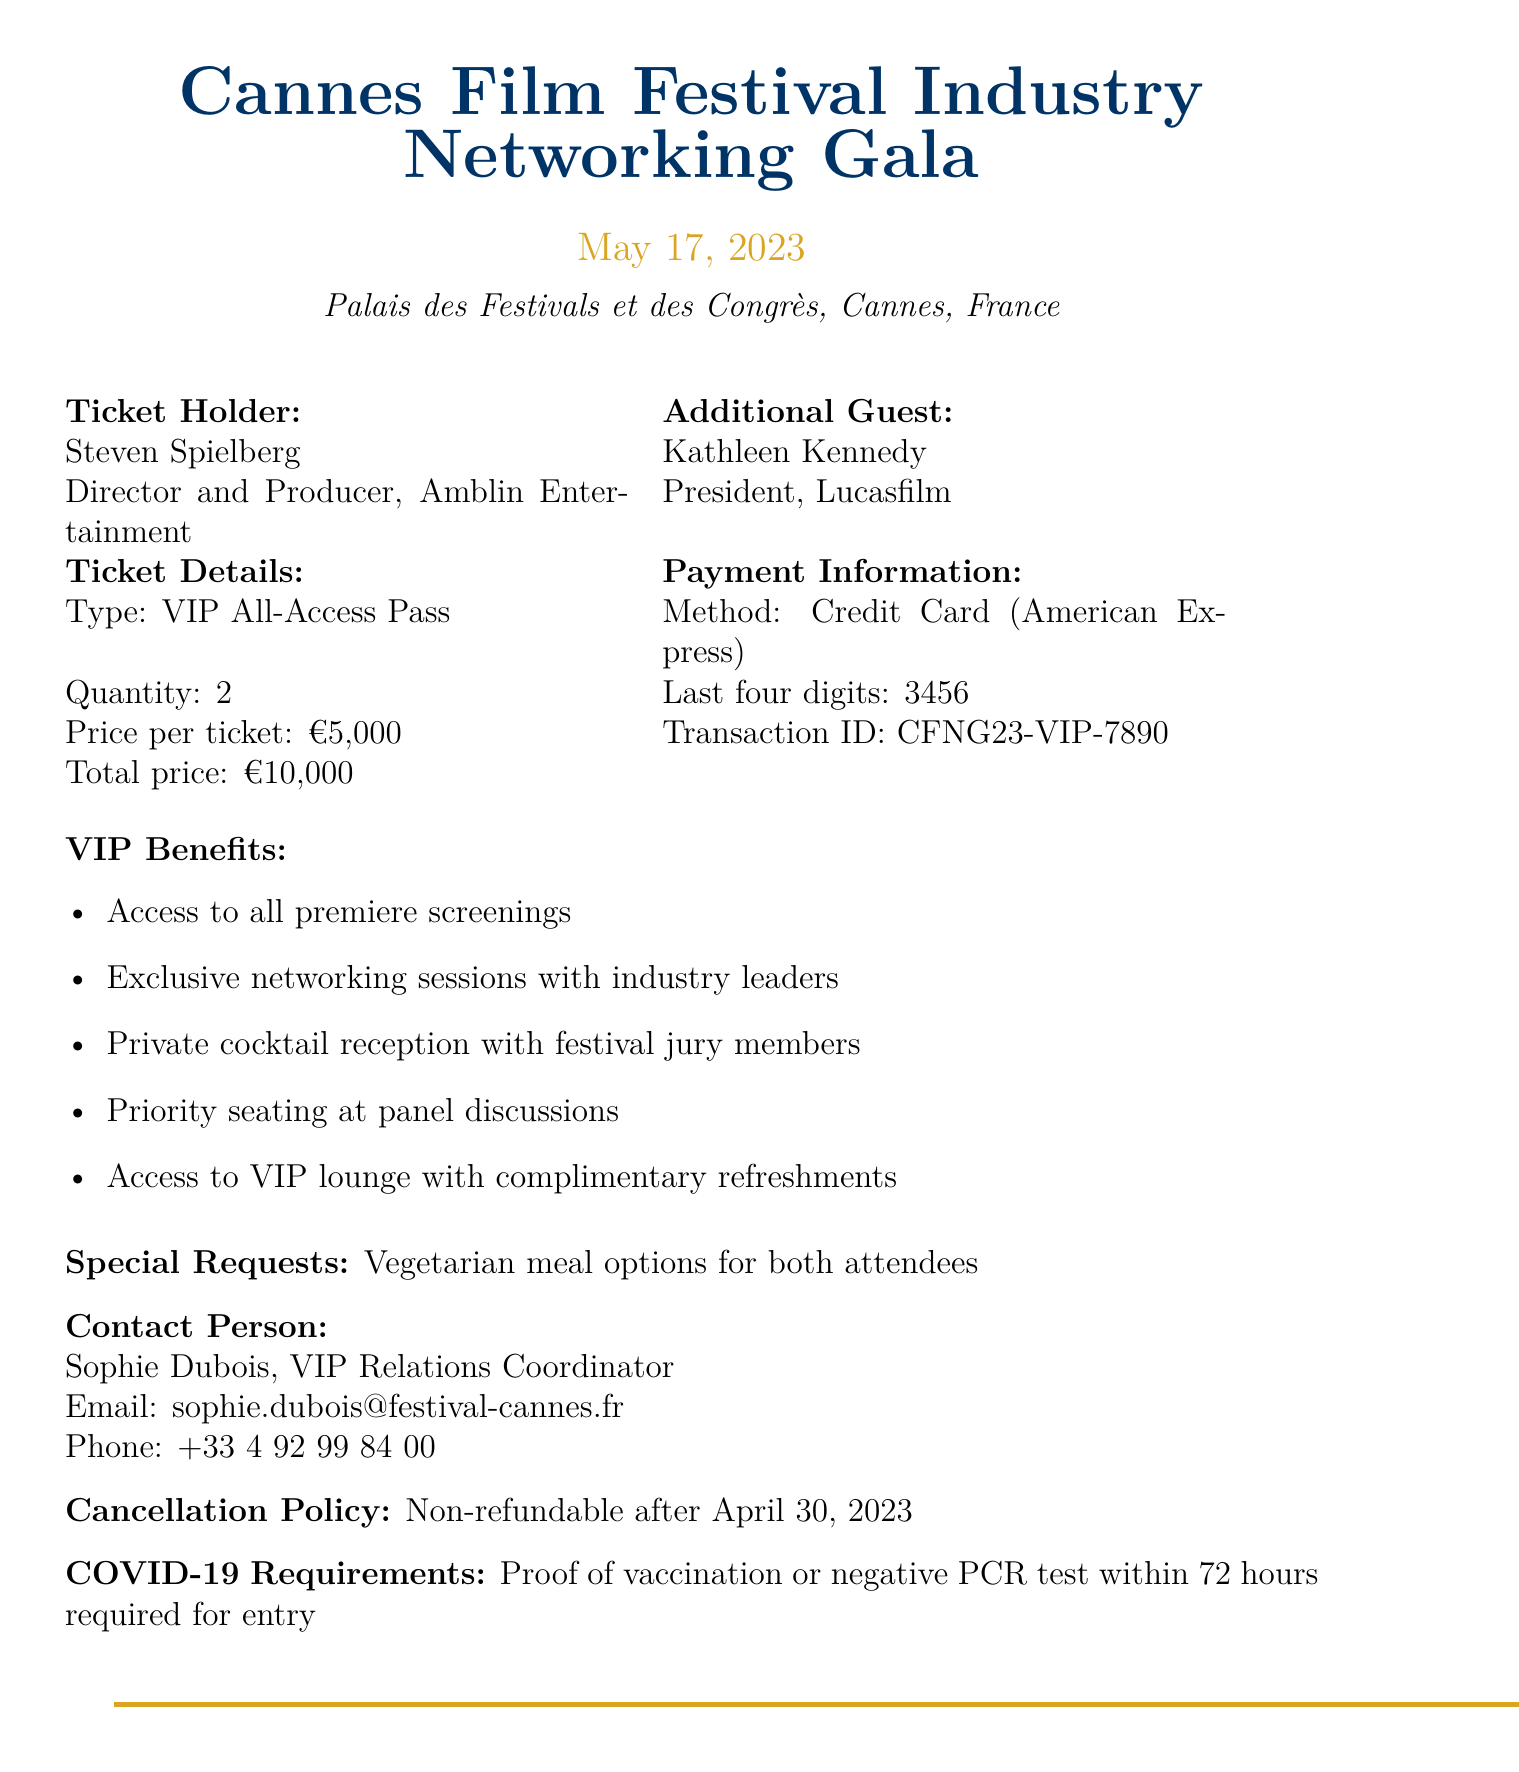what is the event name? The event name is explicitly mentioned in the document as the title of the gala.
Answer: Cannes Film Festival Industry Networking Gala what is the event date? The event date is clearly stated in the document as the date of the gala.
Answer: May 17, 2023 who is the ticket holder? The ticket holder is identified in the document with their name and position.
Answer: Steven Spielberg how many tickets were purchased? The quantity of tickets purchased is specified in the ticket details section of the document.
Answer: 2 what is the total price for the tickets? The total price appears in the ticket details section and is the sum of the prices for the tickets purchased.
Answer: 10000 who is the contact person for the event? The document specifies a contact person responsible for VIP relations at the event.
Answer: Sophie Dubois what type of payment method was used? The payment method is described in the payment information portion of the document.
Answer: Credit Card what special meal option was requested? The special requests section mentions the dietary preferences for the attendees.
Answer: Vegetarian meal options what is the cancellation policy? The cancellation policy is detailed in the document regarding refunds and deadlines.
Answer: Non-refundable after April 30, 2023 what are the COVID-19 requirements for entry? The document outlines the conditions regarding health and safety for attending the event.
Answer: Proof of vaccination or negative PCR test within 72 hours required for entry 